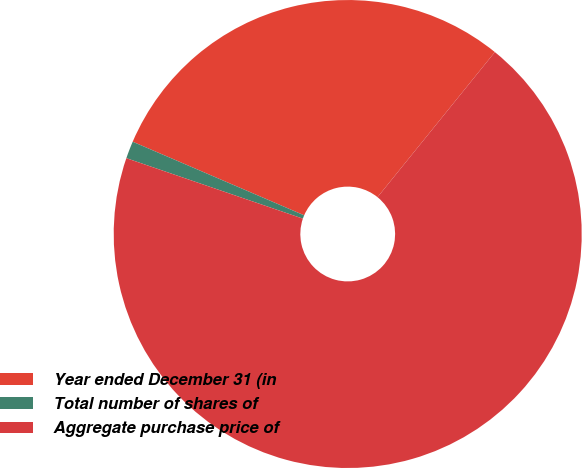Convert chart. <chart><loc_0><loc_0><loc_500><loc_500><pie_chart><fcel>Year ended December 31 (in<fcel>Total number of shares of<fcel>Aggregate purchase price of<nl><fcel>29.37%<fcel>1.2%<fcel>69.43%<nl></chart> 